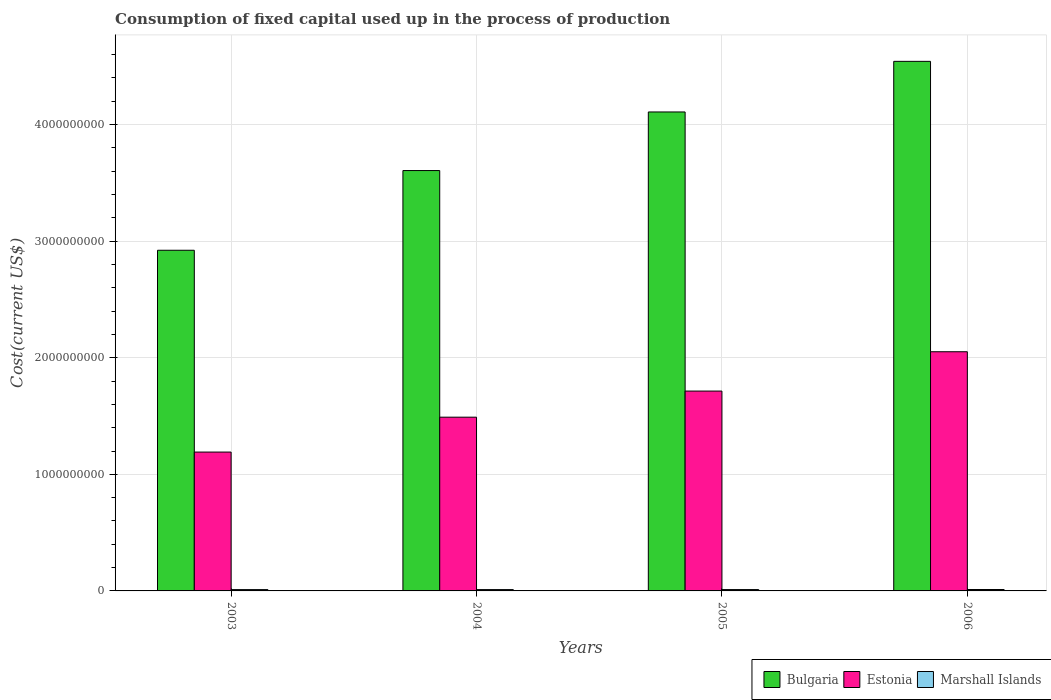How many groups of bars are there?
Your answer should be compact. 4. How many bars are there on the 2nd tick from the right?
Give a very brief answer. 3. What is the label of the 4th group of bars from the left?
Offer a very short reply. 2006. What is the amount consumed in the process of production in Estonia in 2004?
Your response must be concise. 1.49e+09. Across all years, what is the maximum amount consumed in the process of production in Estonia?
Your response must be concise. 2.05e+09. Across all years, what is the minimum amount consumed in the process of production in Bulgaria?
Ensure brevity in your answer.  2.92e+09. What is the total amount consumed in the process of production in Marshall Islands in the graph?
Offer a terse response. 4.66e+07. What is the difference between the amount consumed in the process of production in Bulgaria in 2004 and that in 2006?
Give a very brief answer. -9.37e+08. What is the difference between the amount consumed in the process of production in Bulgaria in 2003 and the amount consumed in the process of production in Marshall Islands in 2004?
Provide a succinct answer. 2.91e+09. What is the average amount consumed in the process of production in Marshall Islands per year?
Make the answer very short. 1.16e+07. In the year 2004, what is the difference between the amount consumed in the process of production in Bulgaria and amount consumed in the process of production in Estonia?
Give a very brief answer. 2.12e+09. In how many years, is the amount consumed in the process of production in Bulgaria greater than 1000000000 US$?
Keep it short and to the point. 4. What is the ratio of the amount consumed in the process of production in Bulgaria in 2003 to that in 2005?
Your response must be concise. 0.71. Is the difference between the amount consumed in the process of production in Bulgaria in 2004 and 2006 greater than the difference between the amount consumed in the process of production in Estonia in 2004 and 2006?
Offer a terse response. No. What is the difference between the highest and the second highest amount consumed in the process of production in Estonia?
Offer a terse response. 3.37e+08. What is the difference between the highest and the lowest amount consumed in the process of production in Estonia?
Provide a short and direct response. 8.60e+08. In how many years, is the amount consumed in the process of production in Bulgaria greater than the average amount consumed in the process of production in Bulgaria taken over all years?
Keep it short and to the point. 2. What does the 1st bar from the left in 2006 represents?
Your answer should be compact. Bulgaria. What does the 1st bar from the right in 2003 represents?
Give a very brief answer. Marshall Islands. Is it the case that in every year, the sum of the amount consumed in the process of production in Marshall Islands and amount consumed in the process of production in Bulgaria is greater than the amount consumed in the process of production in Estonia?
Ensure brevity in your answer.  Yes. How many years are there in the graph?
Your answer should be compact. 4. Does the graph contain any zero values?
Offer a terse response. No. Does the graph contain grids?
Provide a short and direct response. Yes. What is the title of the graph?
Provide a short and direct response. Consumption of fixed capital used up in the process of production. Does "Europe(all income levels)" appear as one of the legend labels in the graph?
Your response must be concise. No. What is the label or title of the Y-axis?
Keep it short and to the point. Cost(current US$). What is the Cost(current US$) of Bulgaria in 2003?
Make the answer very short. 2.92e+09. What is the Cost(current US$) in Estonia in 2003?
Your response must be concise. 1.19e+09. What is the Cost(current US$) of Marshall Islands in 2003?
Provide a succinct answer. 1.13e+07. What is the Cost(current US$) in Bulgaria in 2004?
Keep it short and to the point. 3.61e+09. What is the Cost(current US$) of Estonia in 2004?
Your response must be concise. 1.49e+09. What is the Cost(current US$) in Marshall Islands in 2004?
Offer a terse response. 1.14e+07. What is the Cost(current US$) in Bulgaria in 2005?
Provide a short and direct response. 4.11e+09. What is the Cost(current US$) of Estonia in 2005?
Your answer should be compact. 1.71e+09. What is the Cost(current US$) in Marshall Islands in 2005?
Your response must be concise. 1.16e+07. What is the Cost(current US$) in Bulgaria in 2006?
Ensure brevity in your answer.  4.54e+09. What is the Cost(current US$) of Estonia in 2006?
Make the answer very short. 2.05e+09. What is the Cost(current US$) in Marshall Islands in 2006?
Your response must be concise. 1.22e+07. Across all years, what is the maximum Cost(current US$) of Bulgaria?
Ensure brevity in your answer.  4.54e+09. Across all years, what is the maximum Cost(current US$) of Estonia?
Make the answer very short. 2.05e+09. Across all years, what is the maximum Cost(current US$) in Marshall Islands?
Your answer should be very brief. 1.22e+07. Across all years, what is the minimum Cost(current US$) in Bulgaria?
Keep it short and to the point. 2.92e+09. Across all years, what is the minimum Cost(current US$) in Estonia?
Make the answer very short. 1.19e+09. Across all years, what is the minimum Cost(current US$) of Marshall Islands?
Ensure brevity in your answer.  1.13e+07. What is the total Cost(current US$) of Bulgaria in the graph?
Make the answer very short. 1.52e+1. What is the total Cost(current US$) of Estonia in the graph?
Keep it short and to the point. 6.45e+09. What is the total Cost(current US$) in Marshall Islands in the graph?
Make the answer very short. 4.66e+07. What is the difference between the Cost(current US$) in Bulgaria in 2003 and that in 2004?
Provide a short and direct response. -6.83e+08. What is the difference between the Cost(current US$) in Estonia in 2003 and that in 2004?
Your answer should be compact. -2.99e+08. What is the difference between the Cost(current US$) in Marshall Islands in 2003 and that in 2004?
Your answer should be compact. -1.17e+05. What is the difference between the Cost(current US$) of Bulgaria in 2003 and that in 2005?
Make the answer very short. -1.19e+09. What is the difference between the Cost(current US$) in Estonia in 2003 and that in 2005?
Keep it short and to the point. -5.23e+08. What is the difference between the Cost(current US$) of Marshall Islands in 2003 and that in 2005?
Give a very brief answer. -3.10e+05. What is the difference between the Cost(current US$) in Bulgaria in 2003 and that in 2006?
Give a very brief answer. -1.62e+09. What is the difference between the Cost(current US$) of Estonia in 2003 and that in 2006?
Keep it short and to the point. -8.60e+08. What is the difference between the Cost(current US$) in Marshall Islands in 2003 and that in 2006?
Your answer should be compact. -8.47e+05. What is the difference between the Cost(current US$) in Bulgaria in 2004 and that in 2005?
Provide a succinct answer. -5.03e+08. What is the difference between the Cost(current US$) in Estonia in 2004 and that in 2005?
Keep it short and to the point. -2.24e+08. What is the difference between the Cost(current US$) in Marshall Islands in 2004 and that in 2005?
Provide a short and direct response. -1.93e+05. What is the difference between the Cost(current US$) in Bulgaria in 2004 and that in 2006?
Make the answer very short. -9.37e+08. What is the difference between the Cost(current US$) in Estonia in 2004 and that in 2006?
Provide a succinct answer. -5.61e+08. What is the difference between the Cost(current US$) of Marshall Islands in 2004 and that in 2006?
Offer a terse response. -7.30e+05. What is the difference between the Cost(current US$) in Bulgaria in 2005 and that in 2006?
Make the answer very short. -4.34e+08. What is the difference between the Cost(current US$) of Estonia in 2005 and that in 2006?
Keep it short and to the point. -3.37e+08. What is the difference between the Cost(current US$) in Marshall Islands in 2005 and that in 2006?
Keep it short and to the point. -5.37e+05. What is the difference between the Cost(current US$) of Bulgaria in 2003 and the Cost(current US$) of Estonia in 2004?
Provide a short and direct response. 1.43e+09. What is the difference between the Cost(current US$) of Bulgaria in 2003 and the Cost(current US$) of Marshall Islands in 2004?
Provide a short and direct response. 2.91e+09. What is the difference between the Cost(current US$) in Estonia in 2003 and the Cost(current US$) in Marshall Islands in 2004?
Your answer should be compact. 1.18e+09. What is the difference between the Cost(current US$) of Bulgaria in 2003 and the Cost(current US$) of Estonia in 2005?
Your response must be concise. 1.21e+09. What is the difference between the Cost(current US$) in Bulgaria in 2003 and the Cost(current US$) in Marshall Islands in 2005?
Make the answer very short. 2.91e+09. What is the difference between the Cost(current US$) of Estonia in 2003 and the Cost(current US$) of Marshall Islands in 2005?
Give a very brief answer. 1.18e+09. What is the difference between the Cost(current US$) of Bulgaria in 2003 and the Cost(current US$) of Estonia in 2006?
Your response must be concise. 8.70e+08. What is the difference between the Cost(current US$) in Bulgaria in 2003 and the Cost(current US$) in Marshall Islands in 2006?
Your response must be concise. 2.91e+09. What is the difference between the Cost(current US$) in Estonia in 2003 and the Cost(current US$) in Marshall Islands in 2006?
Your answer should be very brief. 1.18e+09. What is the difference between the Cost(current US$) of Bulgaria in 2004 and the Cost(current US$) of Estonia in 2005?
Your answer should be compact. 1.89e+09. What is the difference between the Cost(current US$) of Bulgaria in 2004 and the Cost(current US$) of Marshall Islands in 2005?
Offer a very short reply. 3.59e+09. What is the difference between the Cost(current US$) in Estonia in 2004 and the Cost(current US$) in Marshall Islands in 2005?
Keep it short and to the point. 1.48e+09. What is the difference between the Cost(current US$) of Bulgaria in 2004 and the Cost(current US$) of Estonia in 2006?
Your response must be concise. 1.55e+09. What is the difference between the Cost(current US$) in Bulgaria in 2004 and the Cost(current US$) in Marshall Islands in 2006?
Make the answer very short. 3.59e+09. What is the difference between the Cost(current US$) of Estonia in 2004 and the Cost(current US$) of Marshall Islands in 2006?
Offer a very short reply. 1.48e+09. What is the difference between the Cost(current US$) in Bulgaria in 2005 and the Cost(current US$) in Estonia in 2006?
Provide a short and direct response. 2.06e+09. What is the difference between the Cost(current US$) in Bulgaria in 2005 and the Cost(current US$) in Marshall Islands in 2006?
Your answer should be compact. 4.10e+09. What is the difference between the Cost(current US$) of Estonia in 2005 and the Cost(current US$) of Marshall Islands in 2006?
Make the answer very short. 1.70e+09. What is the average Cost(current US$) in Bulgaria per year?
Offer a very short reply. 3.79e+09. What is the average Cost(current US$) of Estonia per year?
Your answer should be very brief. 1.61e+09. What is the average Cost(current US$) in Marshall Islands per year?
Offer a terse response. 1.16e+07. In the year 2003, what is the difference between the Cost(current US$) of Bulgaria and Cost(current US$) of Estonia?
Offer a very short reply. 1.73e+09. In the year 2003, what is the difference between the Cost(current US$) in Bulgaria and Cost(current US$) in Marshall Islands?
Keep it short and to the point. 2.91e+09. In the year 2003, what is the difference between the Cost(current US$) in Estonia and Cost(current US$) in Marshall Islands?
Give a very brief answer. 1.18e+09. In the year 2004, what is the difference between the Cost(current US$) of Bulgaria and Cost(current US$) of Estonia?
Offer a terse response. 2.12e+09. In the year 2004, what is the difference between the Cost(current US$) of Bulgaria and Cost(current US$) of Marshall Islands?
Provide a short and direct response. 3.59e+09. In the year 2004, what is the difference between the Cost(current US$) in Estonia and Cost(current US$) in Marshall Islands?
Offer a very short reply. 1.48e+09. In the year 2005, what is the difference between the Cost(current US$) in Bulgaria and Cost(current US$) in Estonia?
Ensure brevity in your answer.  2.39e+09. In the year 2005, what is the difference between the Cost(current US$) in Bulgaria and Cost(current US$) in Marshall Islands?
Your answer should be very brief. 4.10e+09. In the year 2005, what is the difference between the Cost(current US$) in Estonia and Cost(current US$) in Marshall Islands?
Give a very brief answer. 1.70e+09. In the year 2006, what is the difference between the Cost(current US$) in Bulgaria and Cost(current US$) in Estonia?
Offer a very short reply. 2.49e+09. In the year 2006, what is the difference between the Cost(current US$) in Bulgaria and Cost(current US$) in Marshall Islands?
Make the answer very short. 4.53e+09. In the year 2006, what is the difference between the Cost(current US$) of Estonia and Cost(current US$) of Marshall Islands?
Offer a terse response. 2.04e+09. What is the ratio of the Cost(current US$) of Bulgaria in 2003 to that in 2004?
Ensure brevity in your answer.  0.81. What is the ratio of the Cost(current US$) in Estonia in 2003 to that in 2004?
Provide a short and direct response. 0.8. What is the ratio of the Cost(current US$) of Bulgaria in 2003 to that in 2005?
Ensure brevity in your answer.  0.71. What is the ratio of the Cost(current US$) in Estonia in 2003 to that in 2005?
Your answer should be compact. 0.69. What is the ratio of the Cost(current US$) in Marshall Islands in 2003 to that in 2005?
Ensure brevity in your answer.  0.97. What is the ratio of the Cost(current US$) of Bulgaria in 2003 to that in 2006?
Offer a very short reply. 0.64. What is the ratio of the Cost(current US$) of Estonia in 2003 to that in 2006?
Give a very brief answer. 0.58. What is the ratio of the Cost(current US$) in Marshall Islands in 2003 to that in 2006?
Your answer should be very brief. 0.93. What is the ratio of the Cost(current US$) of Bulgaria in 2004 to that in 2005?
Your response must be concise. 0.88. What is the ratio of the Cost(current US$) of Estonia in 2004 to that in 2005?
Ensure brevity in your answer.  0.87. What is the ratio of the Cost(current US$) of Marshall Islands in 2004 to that in 2005?
Your answer should be compact. 0.98. What is the ratio of the Cost(current US$) of Bulgaria in 2004 to that in 2006?
Keep it short and to the point. 0.79. What is the ratio of the Cost(current US$) in Estonia in 2004 to that in 2006?
Your answer should be very brief. 0.73. What is the ratio of the Cost(current US$) of Marshall Islands in 2004 to that in 2006?
Make the answer very short. 0.94. What is the ratio of the Cost(current US$) of Bulgaria in 2005 to that in 2006?
Provide a short and direct response. 0.9. What is the ratio of the Cost(current US$) of Estonia in 2005 to that in 2006?
Your response must be concise. 0.84. What is the ratio of the Cost(current US$) in Marshall Islands in 2005 to that in 2006?
Give a very brief answer. 0.96. What is the difference between the highest and the second highest Cost(current US$) in Bulgaria?
Offer a very short reply. 4.34e+08. What is the difference between the highest and the second highest Cost(current US$) of Estonia?
Offer a terse response. 3.37e+08. What is the difference between the highest and the second highest Cost(current US$) in Marshall Islands?
Make the answer very short. 5.37e+05. What is the difference between the highest and the lowest Cost(current US$) of Bulgaria?
Provide a succinct answer. 1.62e+09. What is the difference between the highest and the lowest Cost(current US$) in Estonia?
Your response must be concise. 8.60e+08. What is the difference between the highest and the lowest Cost(current US$) of Marshall Islands?
Give a very brief answer. 8.47e+05. 